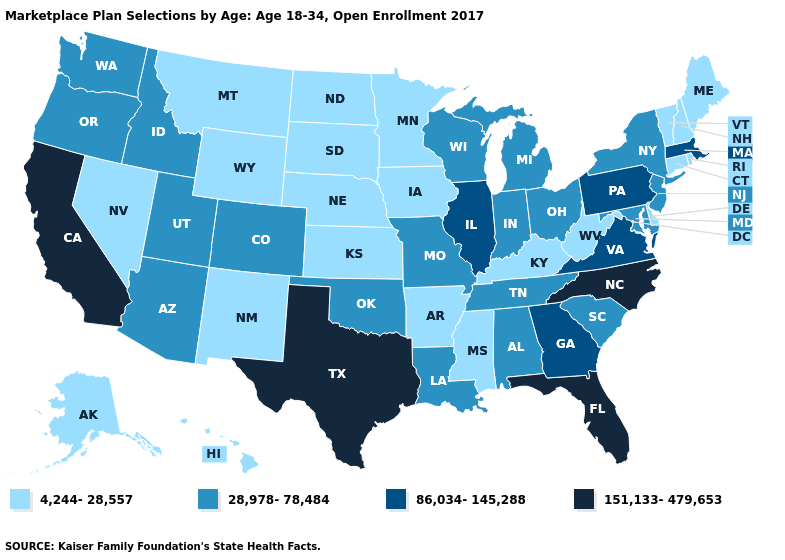Among the states that border Nebraska , does Colorado have the lowest value?
Short answer required. No. Does Montana have the lowest value in the USA?
Be succinct. Yes. Which states have the lowest value in the USA?
Concise answer only. Alaska, Arkansas, Connecticut, Delaware, Hawaii, Iowa, Kansas, Kentucky, Maine, Minnesota, Mississippi, Montana, Nebraska, Nevada, New Hampshire, New Mexico, North Dakota, Rhode Island, South Dakota, Vermont, West Virginia, Wyoming. Which states have the lowest value in the South?
Answer briefly. Arkansas, Delaware, Kentucky, Mississippi, West Virginia. Name the states that have a value in the range 86,034-145,288?
Answer briefly. Georgia, Illinois, Massachusetts, Pennsylvania, Virginia. Does Arizona have the same value as West Virginia?
Give a very brief answer. No. Does Indiana have a higher value than Virginia?
Short answer required. No. Does the map have missing data?
Keep it brief. No. What is the highest value in states that border New Jersey?
Write a very short answer. 86,034-145,288. Name the states that have a value in the range 28,978-78,484?
Short answer required. Alabama, Arizona, Colorado, Idaho, Indiana, Louisiana, Maryland, Michigan, Missouri, New Jersey, New York, Ohio, Oklahoma, Oregon, South Carolina, Tennessee, Utah, Washington, Wisconsin. Does Texas have the highest value in the South?
Concise answer only. Yes. What is the highest value in states that border Oklahoma?
Keep it brief. 151,133-479,653. Does Texas have a lower value than Louisiana?
Give a very brief answer. No. What is the value of Arizona?
Keep it brief. 28,978-78,484. Which states hav the highest value in the Northeast?
Quick response, please. Massachusetts, Pennsylvania. 